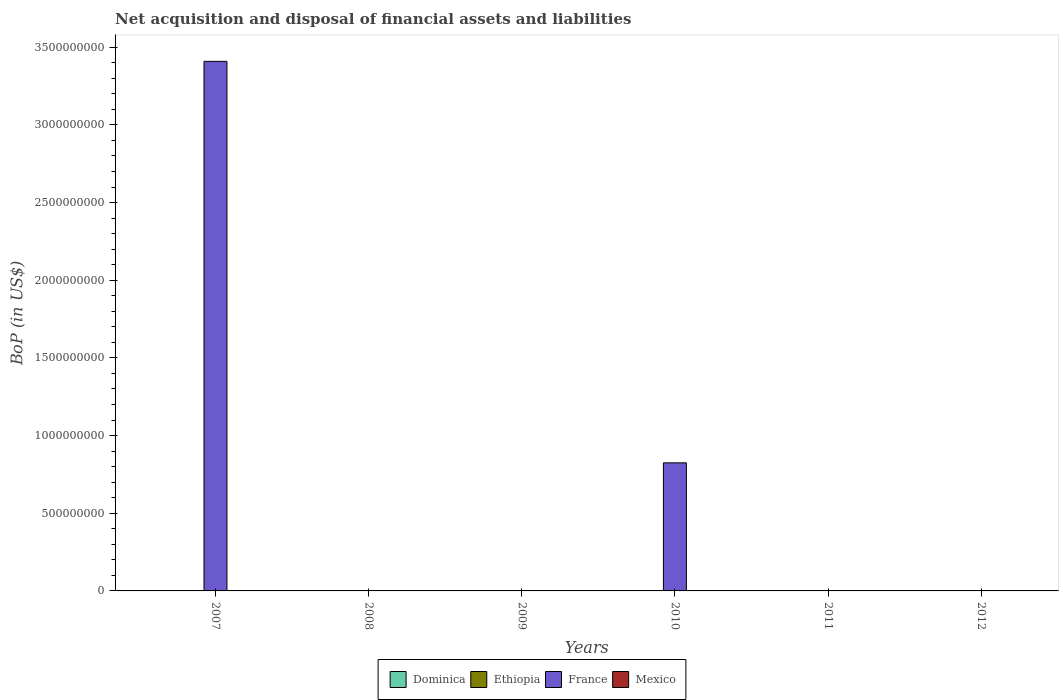How many different coloured bars are there?
Provide a short and direct response. 1. Are the number of bars on each tick of the X-axis equal?
Make the answer very short. No. How many bars are there on the 4th tick from the right?
Make the answer very short. 0. What is the label of the 6th group of bars from the left?
Provide a succinct answer. 2012. In how many cases, is the number of bars for a given year not equal to the number of legend labels?
Offer a very short reply. 6. What is the Balance of Payments in Dominica in 2007?
Provide a short and direct response. 0. Across all years, what is the maximum Balance of Payments in France?
Your answer should be very brief. 3.41e+09. What is the total Balance of Payments in Ethiopia in the graph?
Give a very brief answer. 0. What is the difference between the Balance of Payments in Mexico in 2008 and the Balance of Payments in France in 2010?
Your answer should be compact. -8.25e+08. What is the average Balance of Payments in France per year?
Your answer should be very brief. 7.06e+08. In how many years, is the Balance of Payments in Dominica greater than the average Balance of Payments in Dominica taken over all years?
Make the answer very short. 0. Is it the case that in every year, the sum of the Balance of Payments in Ethiopia and Balance of Payments in France is greater than the sum of Balance of Payments in Mexico and Balance of Payments in Dominica?
Provide a succinct answer. No. How many bars are there?
Offer a very short reply. 2. What is the difference between two consecutive major ticks on the Y-axis?
Ensure brevity in your answer.  5.00e+08. Are the values on the major ticks of Y-axis written in scientific E-notation?
Your response must be concise. No. Does the graph contain grids?
Provide a succinct answer. No. How many legend labels are there?
Provide a succinct answer. 4. How are the legend labels stacked?
Provide a succinct answer. Horizontal. What is the title of the graph?
Your answer should be compact. Net acquisition and disposal of financial assets and liabilities. What is the label or title of the Y-axis?
Your answer should be very brief. BoP (in US$). What is the BoP (in US$) in Ethiopia in 2007?
Your answer should be compact. 0. What is the BoP (in US$) in France in 2007?
Keep it short and to the point. 3.41e+09. What is the BoP (in US$) of Dominica in 2008?
Ensure brevity in your answer.  0. What is the BoP (in US$) of Ethiopia in 2008?
Your answer should be compact. 0. What is the BoP (in US$) in Dominica in 2010?
Your answer should be very brief. 0. What is the BoP (in US$) of France in 2010?
Keep it short and to the point. 8.25e+08. What is the BoP (in US$) in Mexico in 2010?
Keep it short and to the point. 0. What is the BoP (in US$) of Ethiopia in 2011?
Provide a short and direct response. 0. What is the BoP (in US$) in France in 2011?
Offer a terse response. 0. What is the BoP (in US$) of Mexico in 2011?
Keep it short and to the point. 0. What is the BoP (in US$) in France in 2012?
Offer a terse response. 0. Across all years, what is the maximum BoP (in US$) in France?
Provide a succinct answer. 3.41e+09. Across all years, what is the minimum BoP (in US$) in France?
Keep it short and to the point. 0. What is the total BoP (in US$) in France in the graph?
Provide a short and direct response. 4.23e+09. What is the total BoP (in US$) in Mexico in the graph?
Provide a succinct answer. 0. What is the difference between the BoP (in US$) of France in 2007 and that in 2010?
Make the answer very short. 2.58e+09. What is the average BoP (in US$) of Dominica per year?
Make the answer very short. 0. What is the average BoP (in US$) in Ethiopia per year?
Give a very brief answer. 0. What is the average BoP (in US$) of France per year?
Ensure brevity in your answer.  7.06e+08. What is the ratio of the BoP (in US$) in France in 2007 to that in 2010?
Give a very brief answer. 4.13. What is the difference between the highest and the lowest BoP (in US$) of France?
Your answer should be compact. 3.41e+09. 